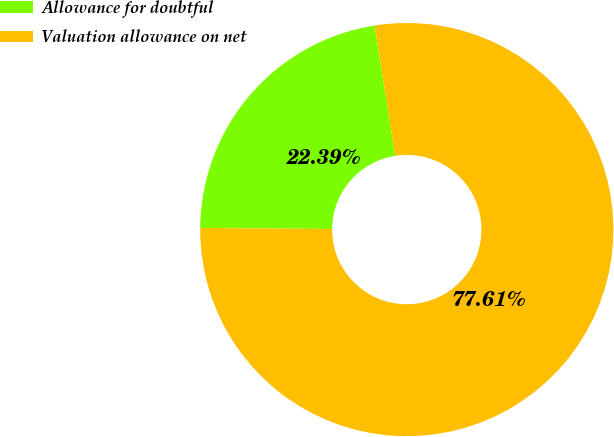Convert chart. <chart><loc_0><loc_0><loc_500><loc_500><pie_chart><fcel>Allowance for doubtful<fcel>Valuation allowance on net<nl><fcel>22.39%<fcel>77.61%<nl></chart> 